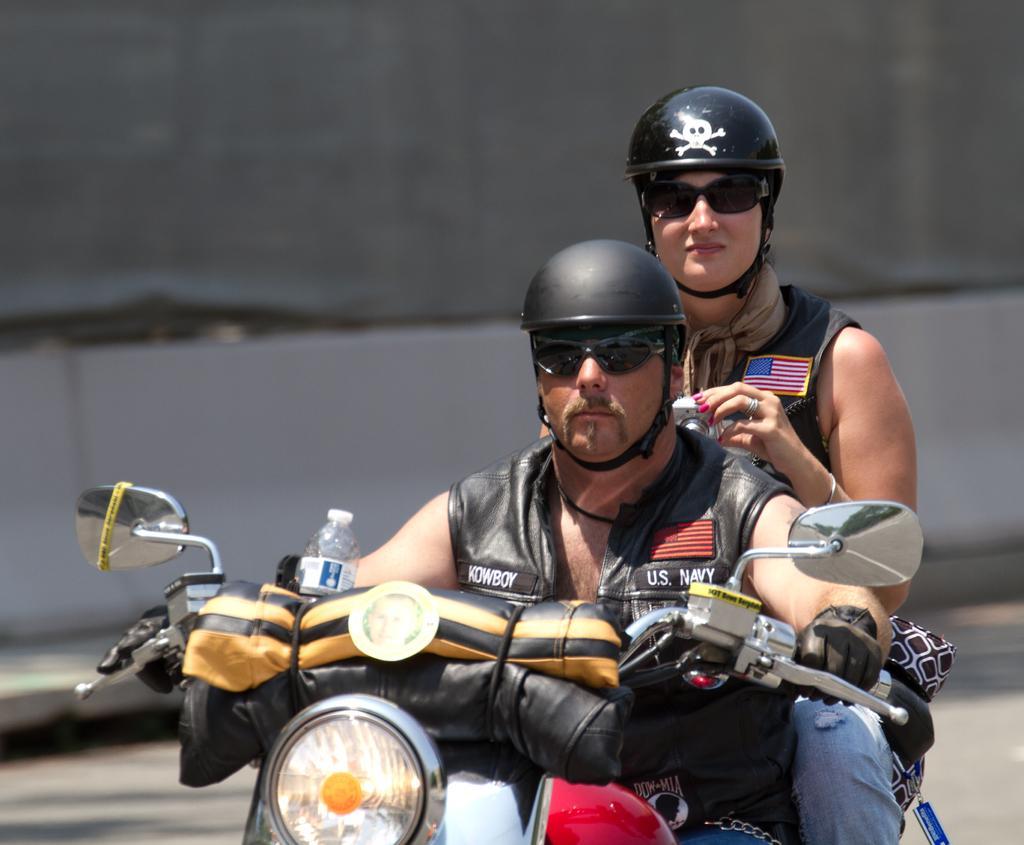Please provide a concise description of this image. In this image I see a man and a woman who are sitting on the bike and both of them are wearing helmets and shades, I can also see there is a bottle over here and the woman is holding a camera. 